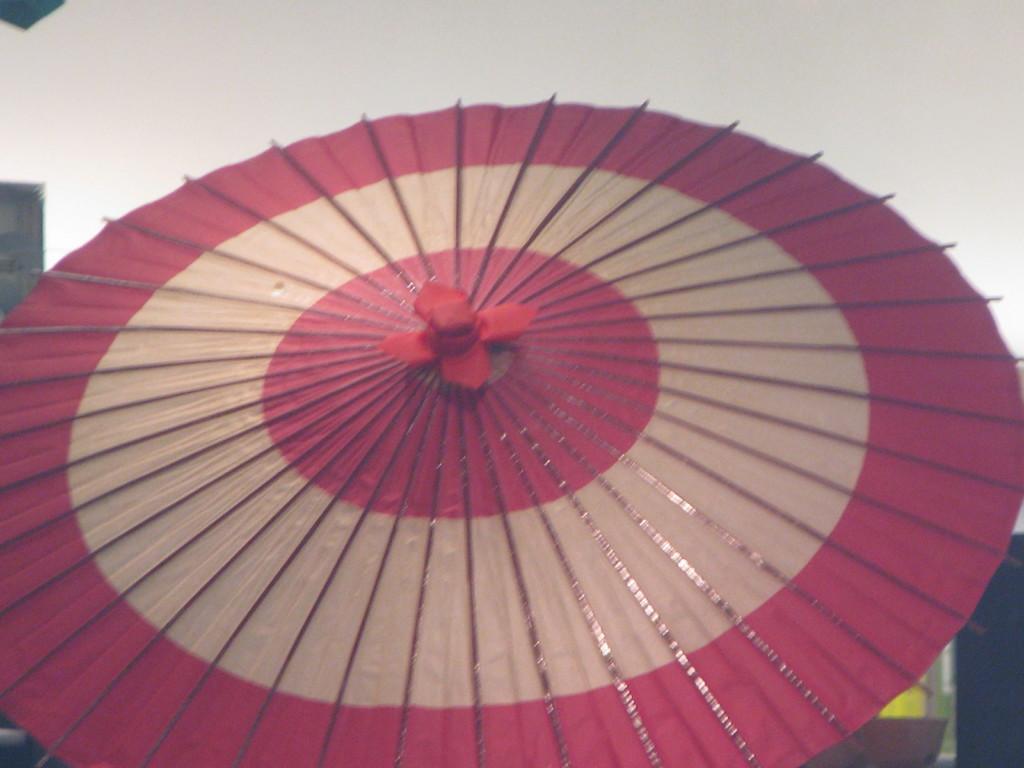In one or two sentences, can you explain what this image depicts? In this picture I can observe an object which is in pink and cream color. It is looking like an umbrella. 